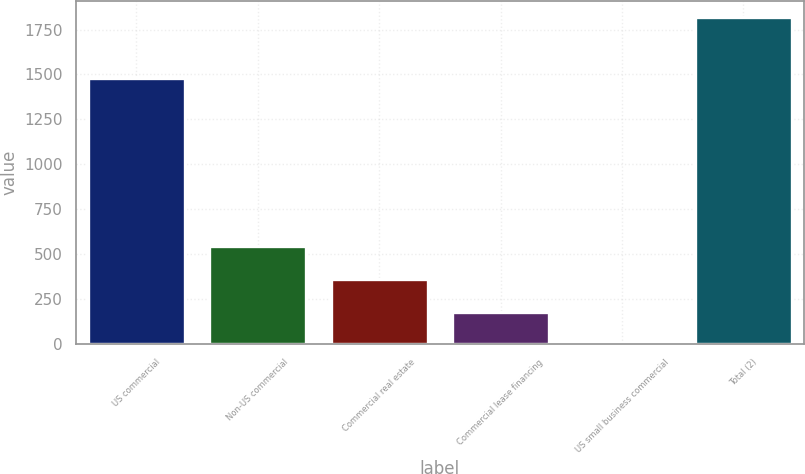<chart> <loc_0><loc_0><loc_500><loc_500><bar_chart><fcel>US commercial<fcel>Non-US commercial<fcel>Commercial real estate<fcel>Commercial lease financing<fcel>US small business commercial<fcel>Total (2)<nl><fcel>1482<fcel>545.8<fcel>364.2<fcel>182.6<fcel>1<fcel>1817<nl></chart> 